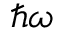<formula> <loc_0><loc_0><loc_500><loc_500>\hbar { \omega }</formula> 